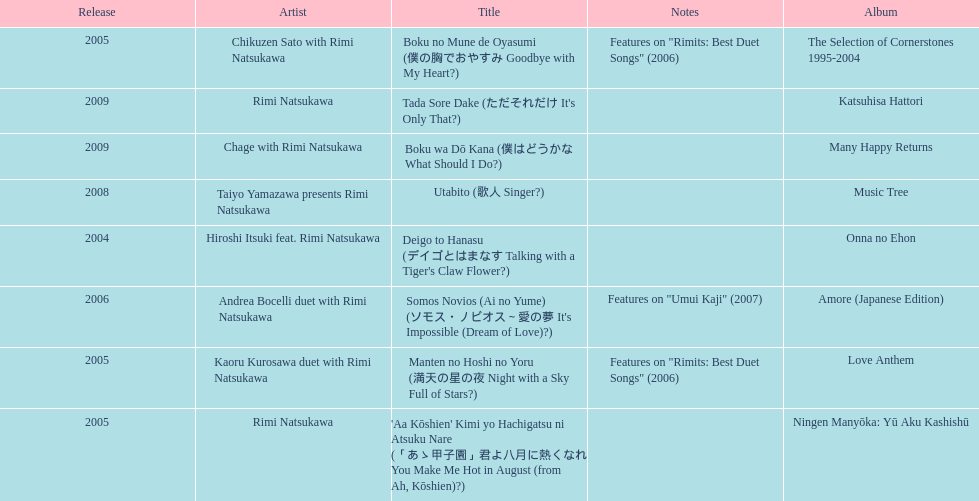Which title has the same notes as night with a sky full of stars? Boku no Mune de Oyasumi (僕の胸でおやすみ Goodbye with My Heart?). 